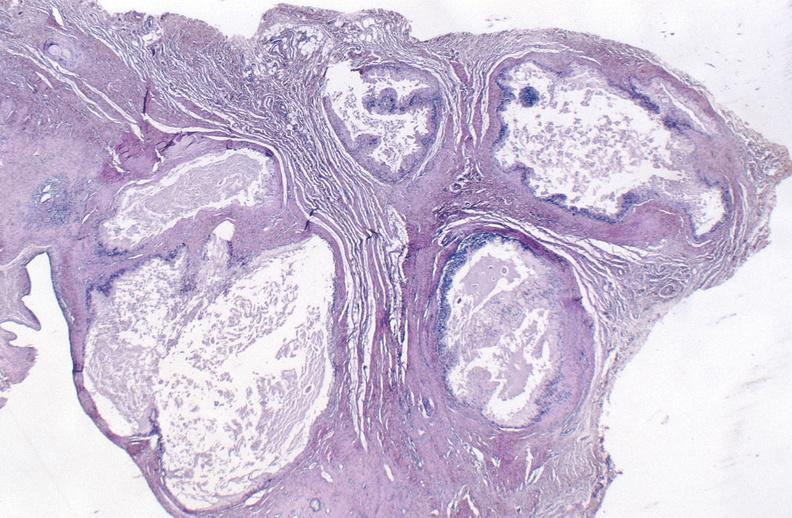does this image show gout?
Answer the question using a single word or phrase. Yes 